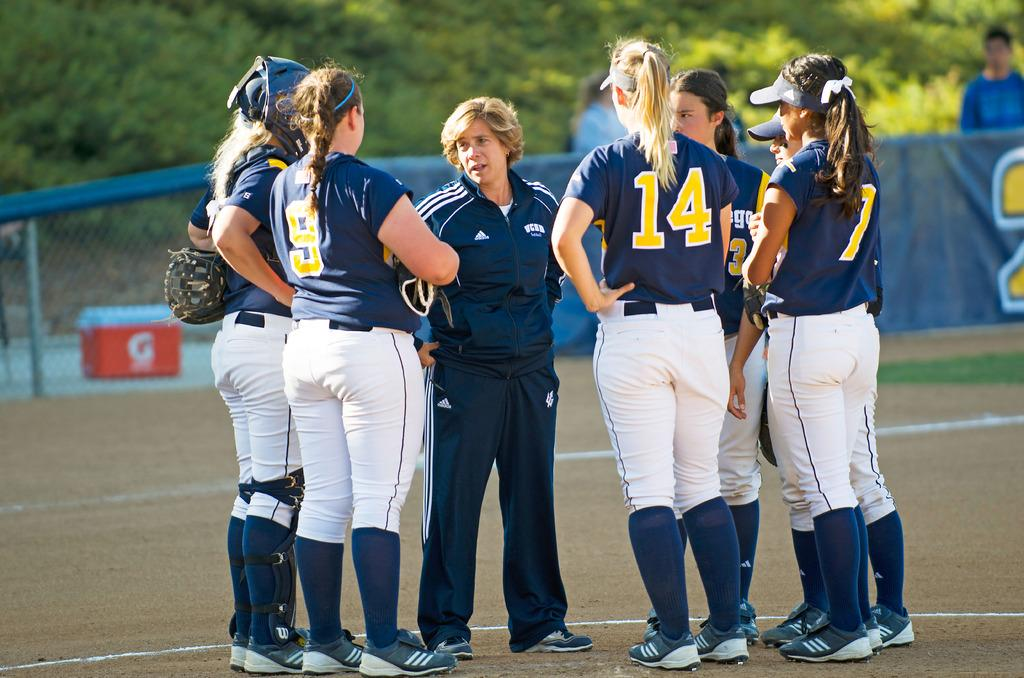Provide a one-sentence caption for the provided image. Many female baseball players one with 14 on her shirt are talking to the coach. 